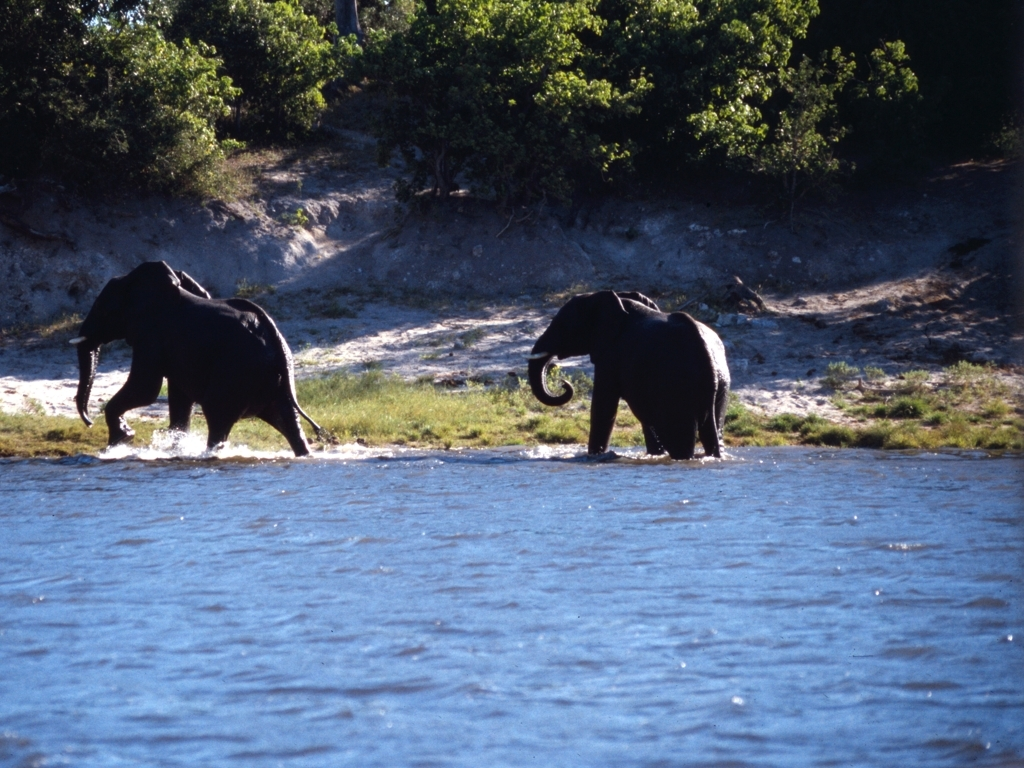Can you tell what kind of environment these elephants are in? These elephants appear to be in a natural habitat, possibly a savanna or a grassland near a water source, given the presence of open landscapes, sparse trees, and a body of water. 